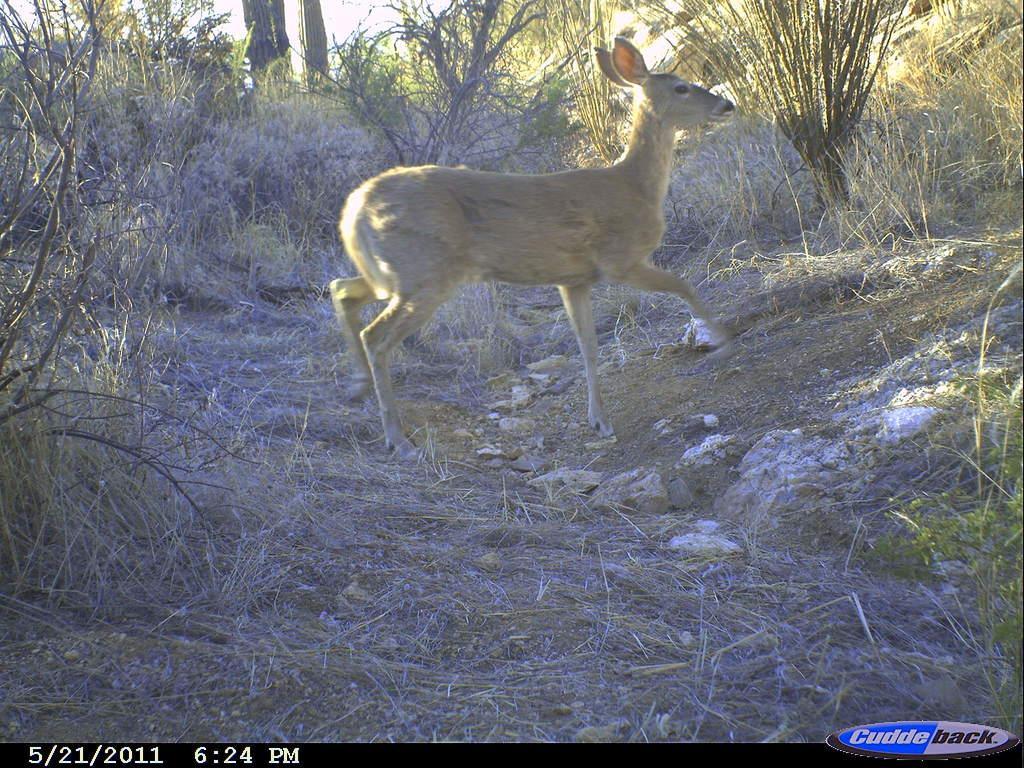Please provide a concise description of this image. In the image there is a deer walking on the dry grassland with plants in the background. 